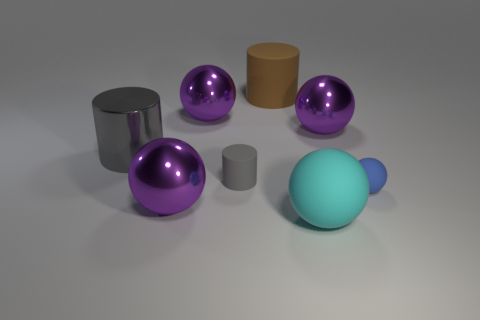Are there any purple metal things?
Offer a very short reply. Yes. There is a cyan ball that is the same material as the blue sphere; what size is it?
Ensure brevity in your answer.  Large. Is the material of the tiny blue object the same as the small gray cylinder?
Offer a very short reply. Yes. How many small objects are both right of the brown thing and to the left of the tiny blue ball?
Provide a short and direct response. 0. The small ball has what color?
Give a very brief answer. Blue. There is another tiny thing that is the same shape as the brown thing; what is it made of?
Offer a terse response. Rubber. Is there anything else that is made of the same material as the small cylinder?
Your response must be concise. Yes. Is the color of the big rubber cylinder the same as the big matte ball?
Your answer should be very brief. No. What shape is the gray matte thing that is on the left side of the purple shiny ball that is to the right of the tiny gray thing?
Offer a very short reply. Cylinder. There is another large object that is made of the same material as the brown thing; what is its shape?
Give a very brief answer. Sphere. 